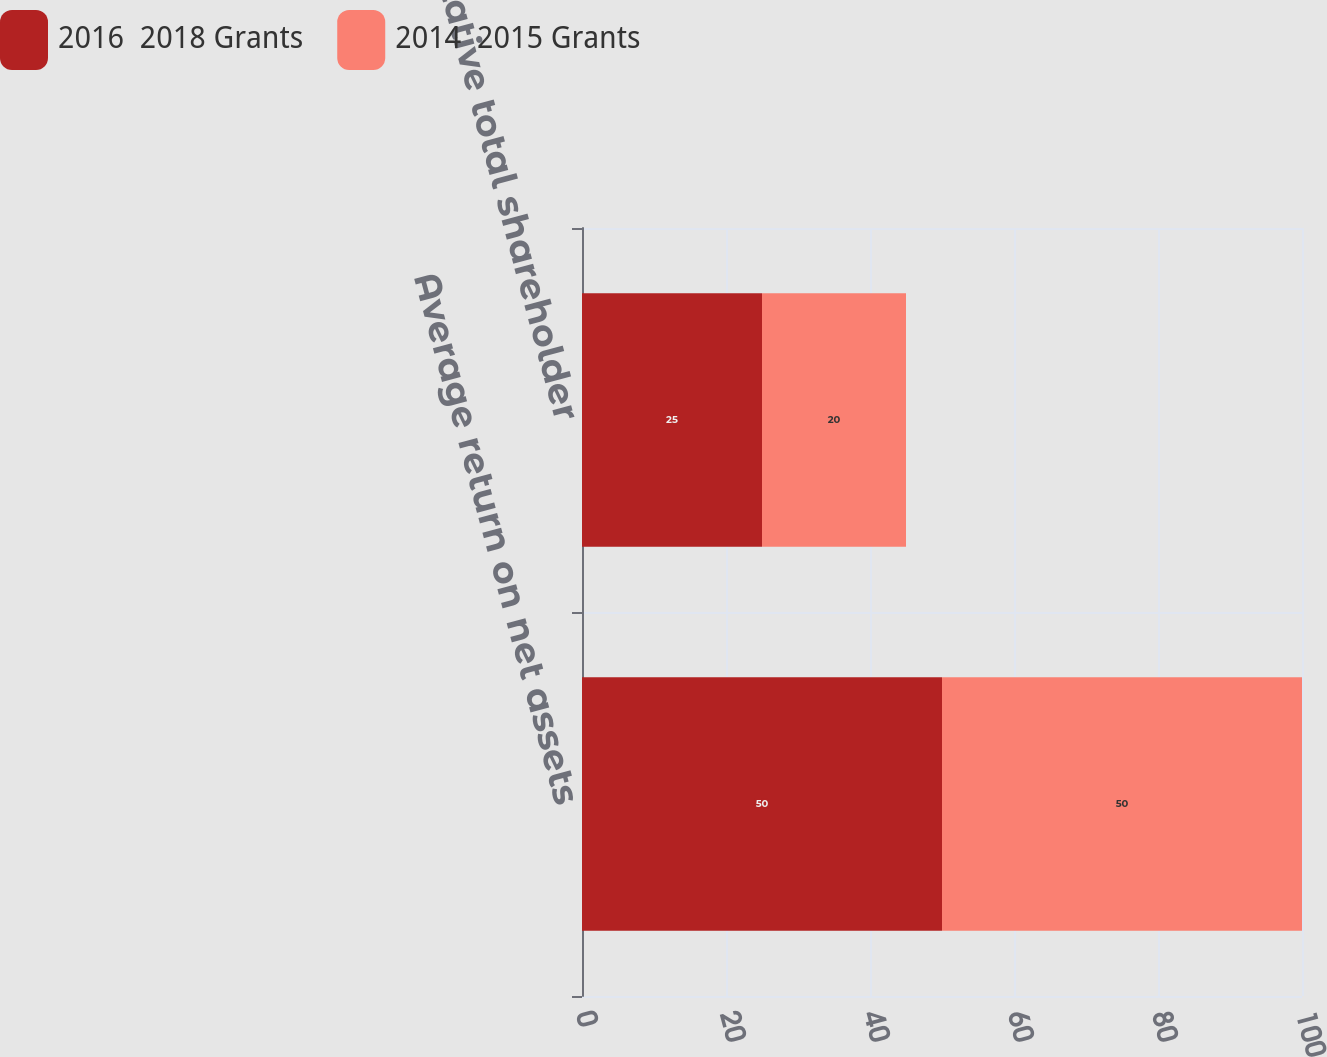<chart> <loc_0><loc_0><loc_500><loc_500><stacked_bar_chart><ecel><fcel>Average return on net assets<fcel>Relative total shareholder<nl><fcel>2016  2018 Grants<fcel>50<fcel>25<nl><fcel>2014  2015 Grants<fcel>50<fcel>20<nl></chart> 